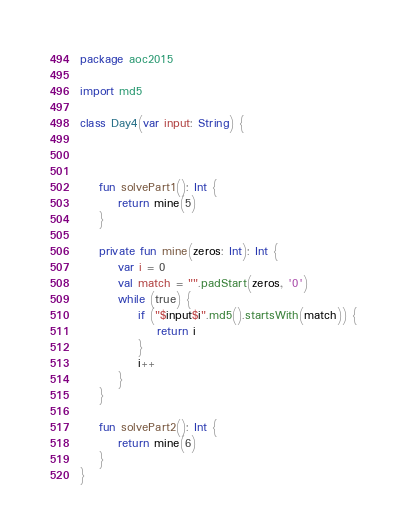<code> <loc_0><loc_0><loc_500><loc_500><_Kotlin_>package aoc2015

import md5

class Day4(var input: String) {



    fun solvePart1(): Int {
        return mine(5)
    }

    private fun mine(zeros: Int): Int {
        var i = 0
        val match = "".padStart(zeros, '0')
        while (true) {
            if ("$input$i".md5().startsWith(match)) {
                return i
            }
            i++
        }
    }

    fun solvePart2(): Int {
        return mine(6)
    }
}</code> 